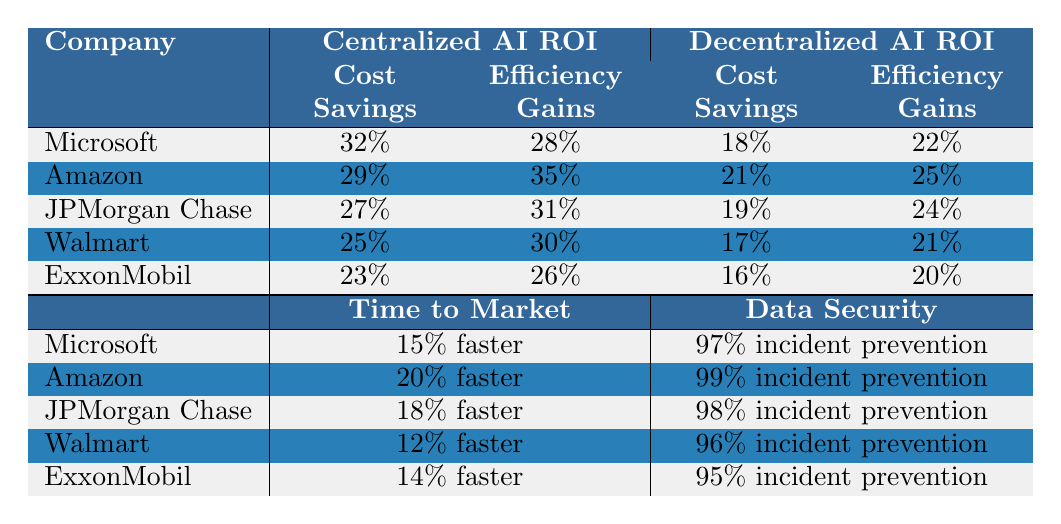What is the cost savings percentage for Microsoft with centralized AI? The table shows that Microsoft has a cost savings of 32% with centralized AI.
Answer: 32% How much faster to market is Amazon with centralized AI compared to decentralized AI? Amazon is 20% faster to market with centralized AI, and 10% faster with decentralized AI. The difference is 20% - 10% = 10%.
Answer: 10% Which company has the highest data security incident prevention rate with centralized AI? Looking at the data, Amazon has the highest data security incident prevention rate at 99% with centralized AI.
Answer: Amazon For which company is the efficiency gain higher in the centralized AI implementation than in the decentralized one? Microsoft, Amazon, JPMorgan Chase, and Walmart all have higher efficiency gains with centralized AI compared to decentralized.
Answer: Microsoft, Amazon, JPMorgan Chase, Walmart What is the average cost savings percentage across all companies for decentralized AI? Adding the cost savings for decentralized AI: 18% + 21% + 19% + 17% + 16% = 91%. Dividing by the number of companies (5) gives an average of 91% / 5 = 18.2%.
Answer: 18.2% Does ExxonMobil have higher efficiency gains in decentralized AI than Walmart? ExxonMobil has 20% efficiency gains with decentralized AI and Walmart has 21%. Thus, Walmart has higher efficiency gains than ExxonMobil.
Answer: No What is the total combined data security incident prevention for all companies with centralized AI? Summing the percentages: 97% + 99% + 98% + 96% + 95% = 485%.
Answer: 485% What is the percentage difference in efficiency gains between the best and worst performing companies in decentralized AI? Amazon has the highest decentralized efficiency gain at 25%, and ExxonMobil has the lowest at 20%. The difference is 25% - 20% = 5%.
Answer: 5% Which company benefits the most from centralized AI in terms of cost savings? Amazon has a cost savings of 29%, which is the highest compared to other companies with centralized AI.
Answer: Amazon Is it true that all companies have a higher percentage of data security incident prevention with centralized AI compared to decentralized AI? Yes, all listed companies show higher data security incident prevention rates with centralized AI than with decentralized AI.
Answer: Yes 